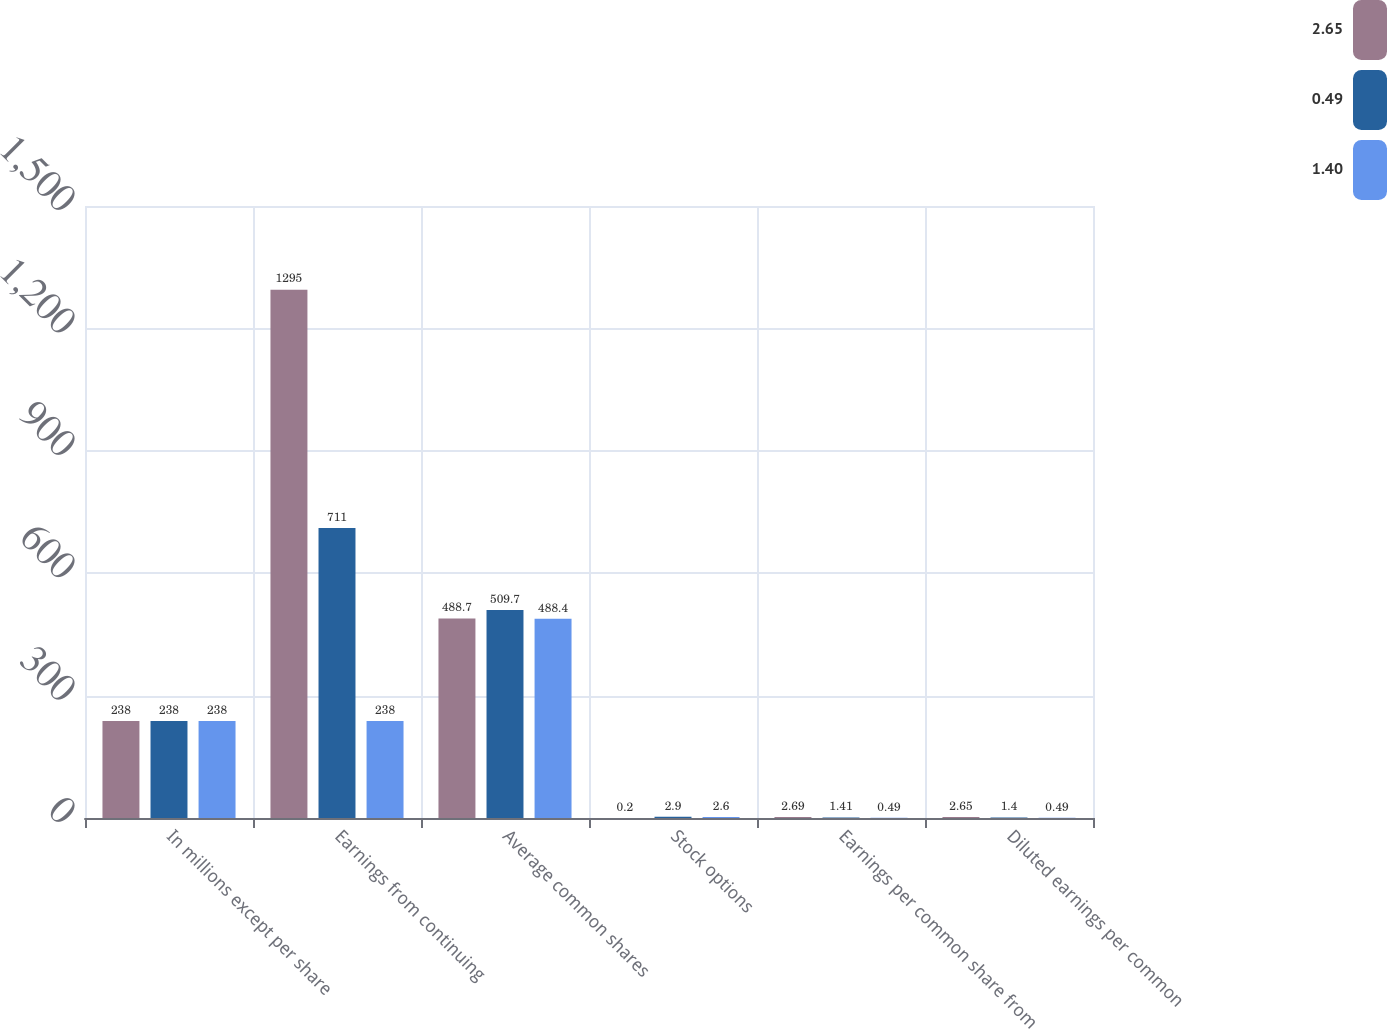Convert chart. <chart><loc_0><loc_0><loc_500><loc_500><stacked_bar_chart><ecel><fcel>In millions except per share<fcel>Earnings from continuing<fcel>Average common shares<fcel>Stock options<fcel>Earnings per common share from<fcel>Diluted earnings per common<nl><fcel>2.65<fcel>238<fcel>1295<fcel>488.7<fcel>0.2<fcel>2.69<fcel>2.65<nl><fcel>0.49<fcel>238<fcel>711<fcel>509.7<fcel>2.9<fcel>1.41<fcel>1.4<nl><fcel>1.4<fcel>238<fcel>238<fcel>488.4<fcel>2.6<fcel>0.49<fcel>0.49<nl></chart> 